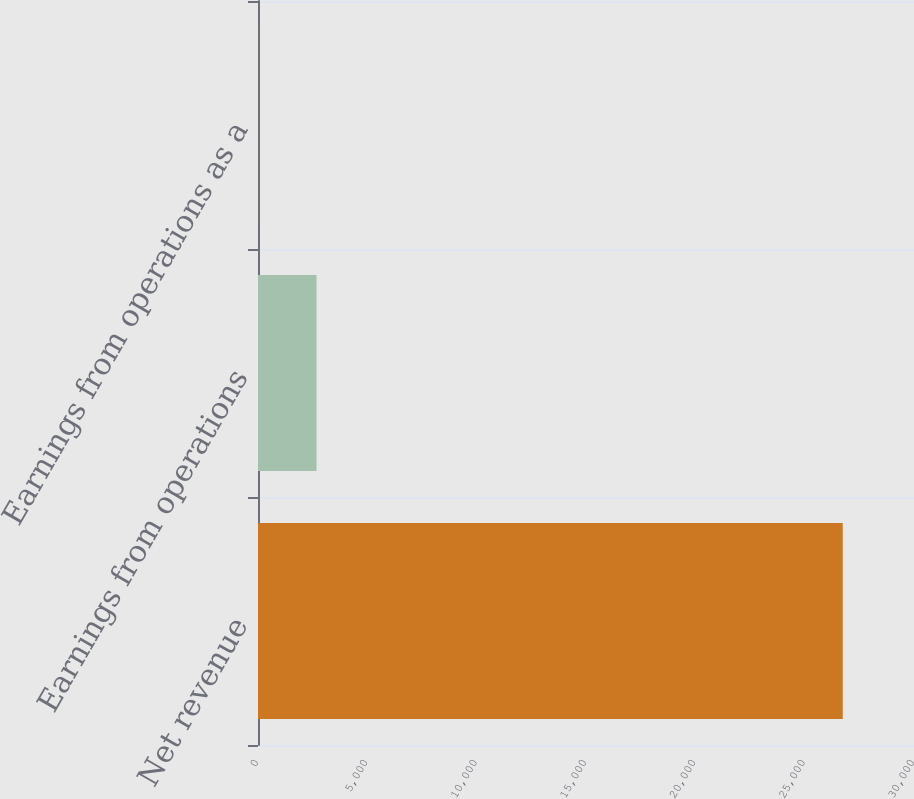<chart> <loc_0><loc_0><loc_500><loc_500><bar_chart><fcel>Net revenue<fcel>Earnings from operations<fcel>Earnings from operations as a<nl><fcel>26741<fcel>2676.35<fcel>2.5<nl></chart> 